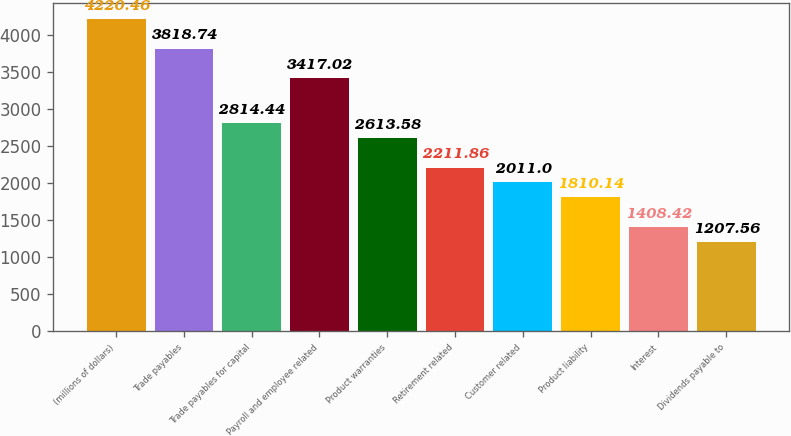Convert chart. <chart><loc_0><loc_0><loc_500><loc_500><bar_chart><fcel>(millions of dollars)<fcel>Trade payables<fcel>Trade payables for capital<fcel>Payroll and employee related<fcel>Product warranties<fcel>Retirement related<fcel>Customer related<fcel>Product liability<fcel>Interest<fcel>Dividends payable to<nl><fcel>4220.46<fcel>3818.74<fcel>2814.44<fcel>3417.02<fcel>2613.58<fcel>2211.86<fcel>2011<fcel>1810.14<fcel>1408.42<fcel>1207.56<nl></chart> 